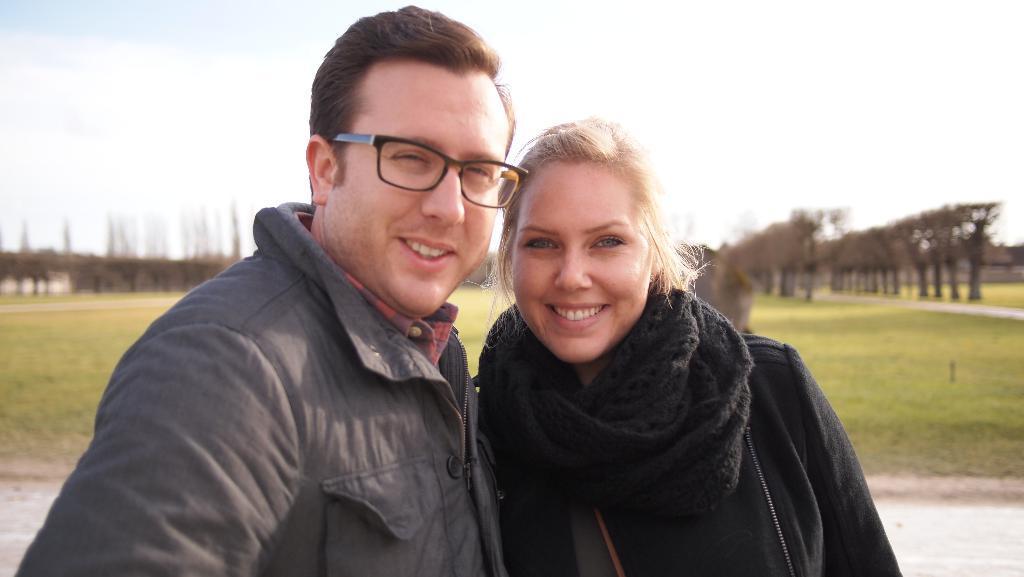Can you describe this image briefly? In this image we can see persons standing on the ground, the background is blurred, one object on the ground looks like a small pole, the background there are some big trees, some roads, some grass on the ground and the top there is the sky. 